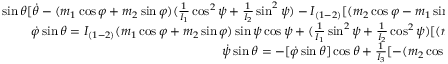<formula> <loc_0><loc_0><loc_500><loc_500>\begin{array} { r } { \sin \theta [ \dot { \theta } - ( m _ { 1 } \cos \varphi + m _ { 2 } \sin \varphi ) ( \frac { 1 } { I _ { 1 } } \cos ^ { 2 } \psi + \frac { 1 } { I _ { 2 } } \sin ^ { 2 } \psi ) - I _ { ( 1 - 2 ) } [ ( m _ { 2 } \cos \varphi - m _ { 1 } \sin \varphi ) \cos \theta + m _ { 3 } \sin \theta ] \sin \psi \cos \psi ] = 0 , \quad } \\ { \dot { \varphi } \sin \theta = I _ { ( 1 - 2 ) } ( m _ { 1 } \cos \varphi + m _ { 2 } \sin \varphi ) \sin \psi \cos \psi + ( \frac { 1 } { I _ { 1 } } \sin ^ { 2 } \psi + \frac { 1 } { I _ { 2 } } \cos ^ { 2 } \psi ) [ ( m _ { 2 } \cos \varphi - m _ { 1 } \sin \varphi ) \cos \theta + m _ { 3 } \sin \theta ] , \quad } \\ { \dot { \psi } \sin \theta = - [ \dot { \varphi } \sin \theta ] \cos \theta + \frac { 1 } { I _ { 3 } } [ - ( m _ { 2 } \cos \varphi - m _ { 1 } \sin \varphi ) \sin ^ { 2 } \theta + m _ { 3 } \sin \theta \cos \theta ] , \quad } \end{array}</formula> 